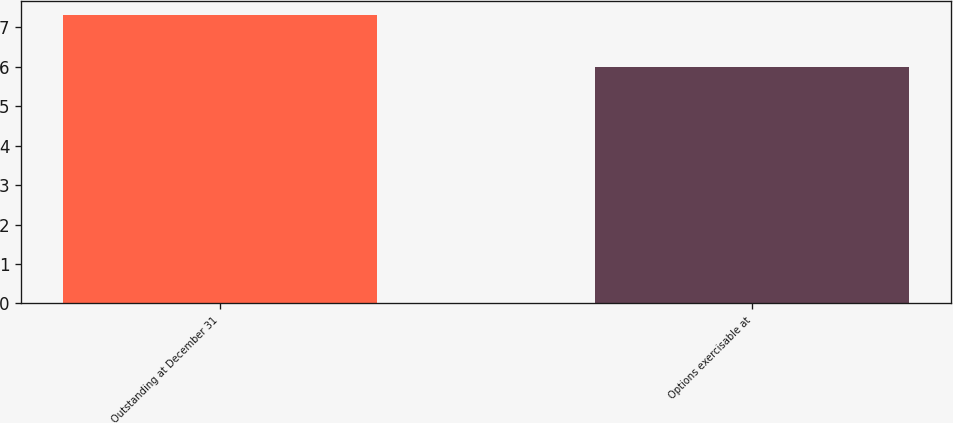Convert chart to OTSL. <chart><loc_0><loc_0><loc_500><loc_500><bar_chart><fcel>Outstanding at December 31<fcel>Options exercisable at<nl><fcel>7.3<fcel>6<nl></chart> 